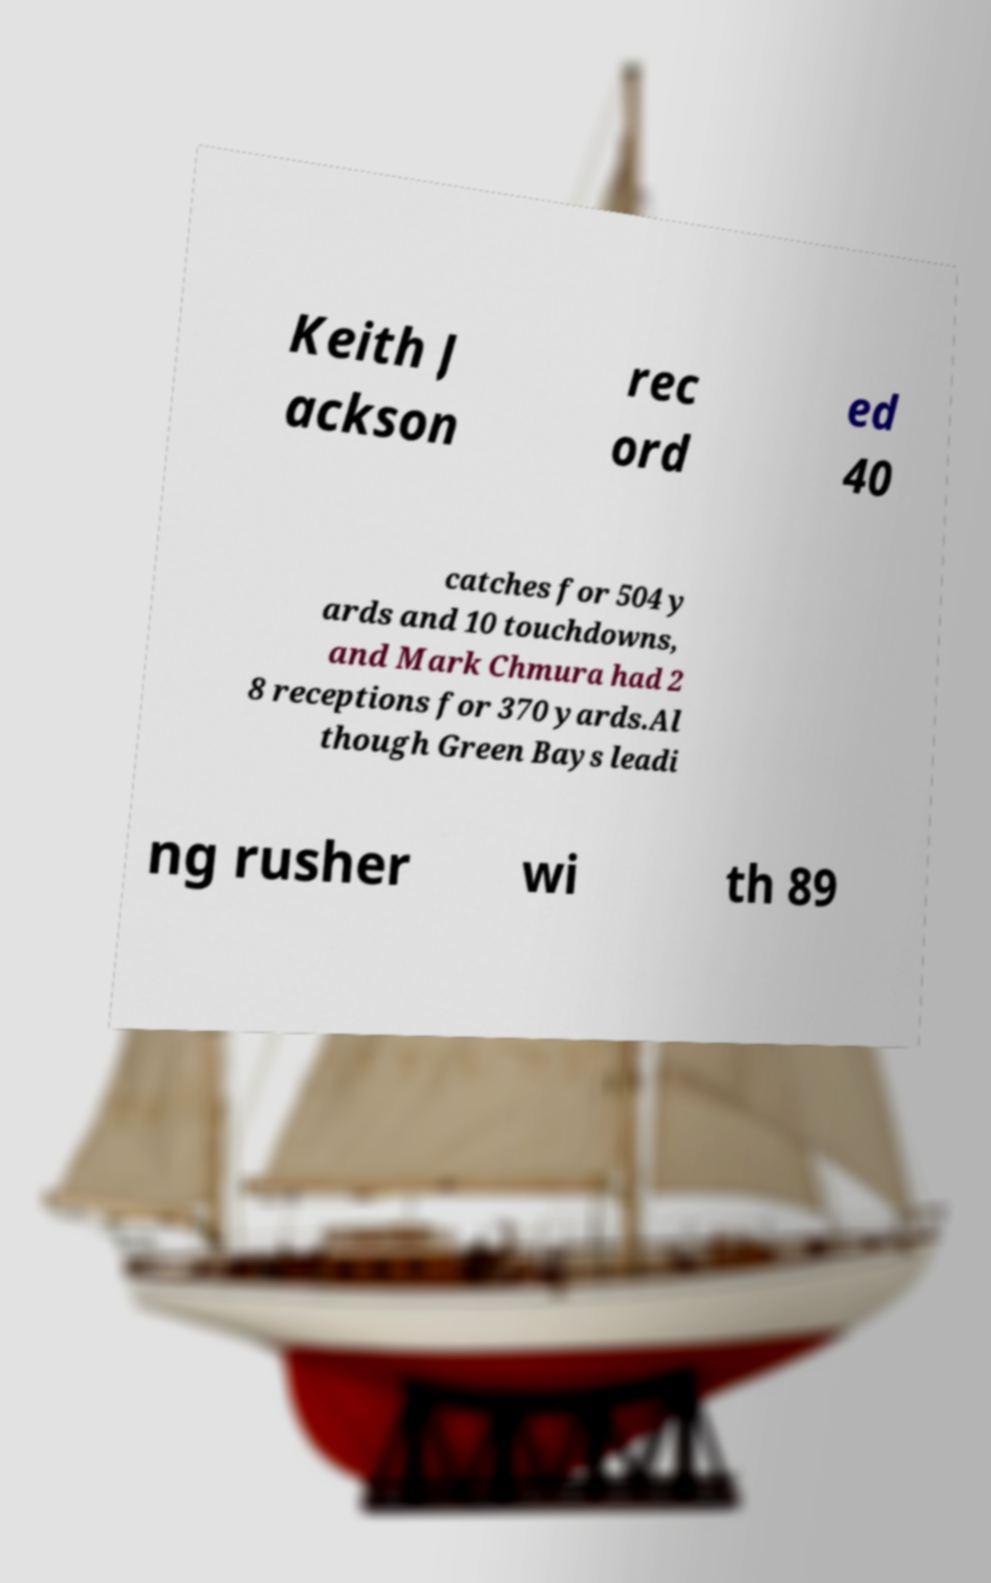Can you read and provide the text displayed in the image?This photo seems to have some interesting text. Can you extract and type it out for me? Keith J ackson rec ord ed 40 catches for 504 y ards and 10 touchdowns, and Mark Chmura had 2 8 receptions for 370 yards.Al though Green Bays leadi ng rusher wi th 89 